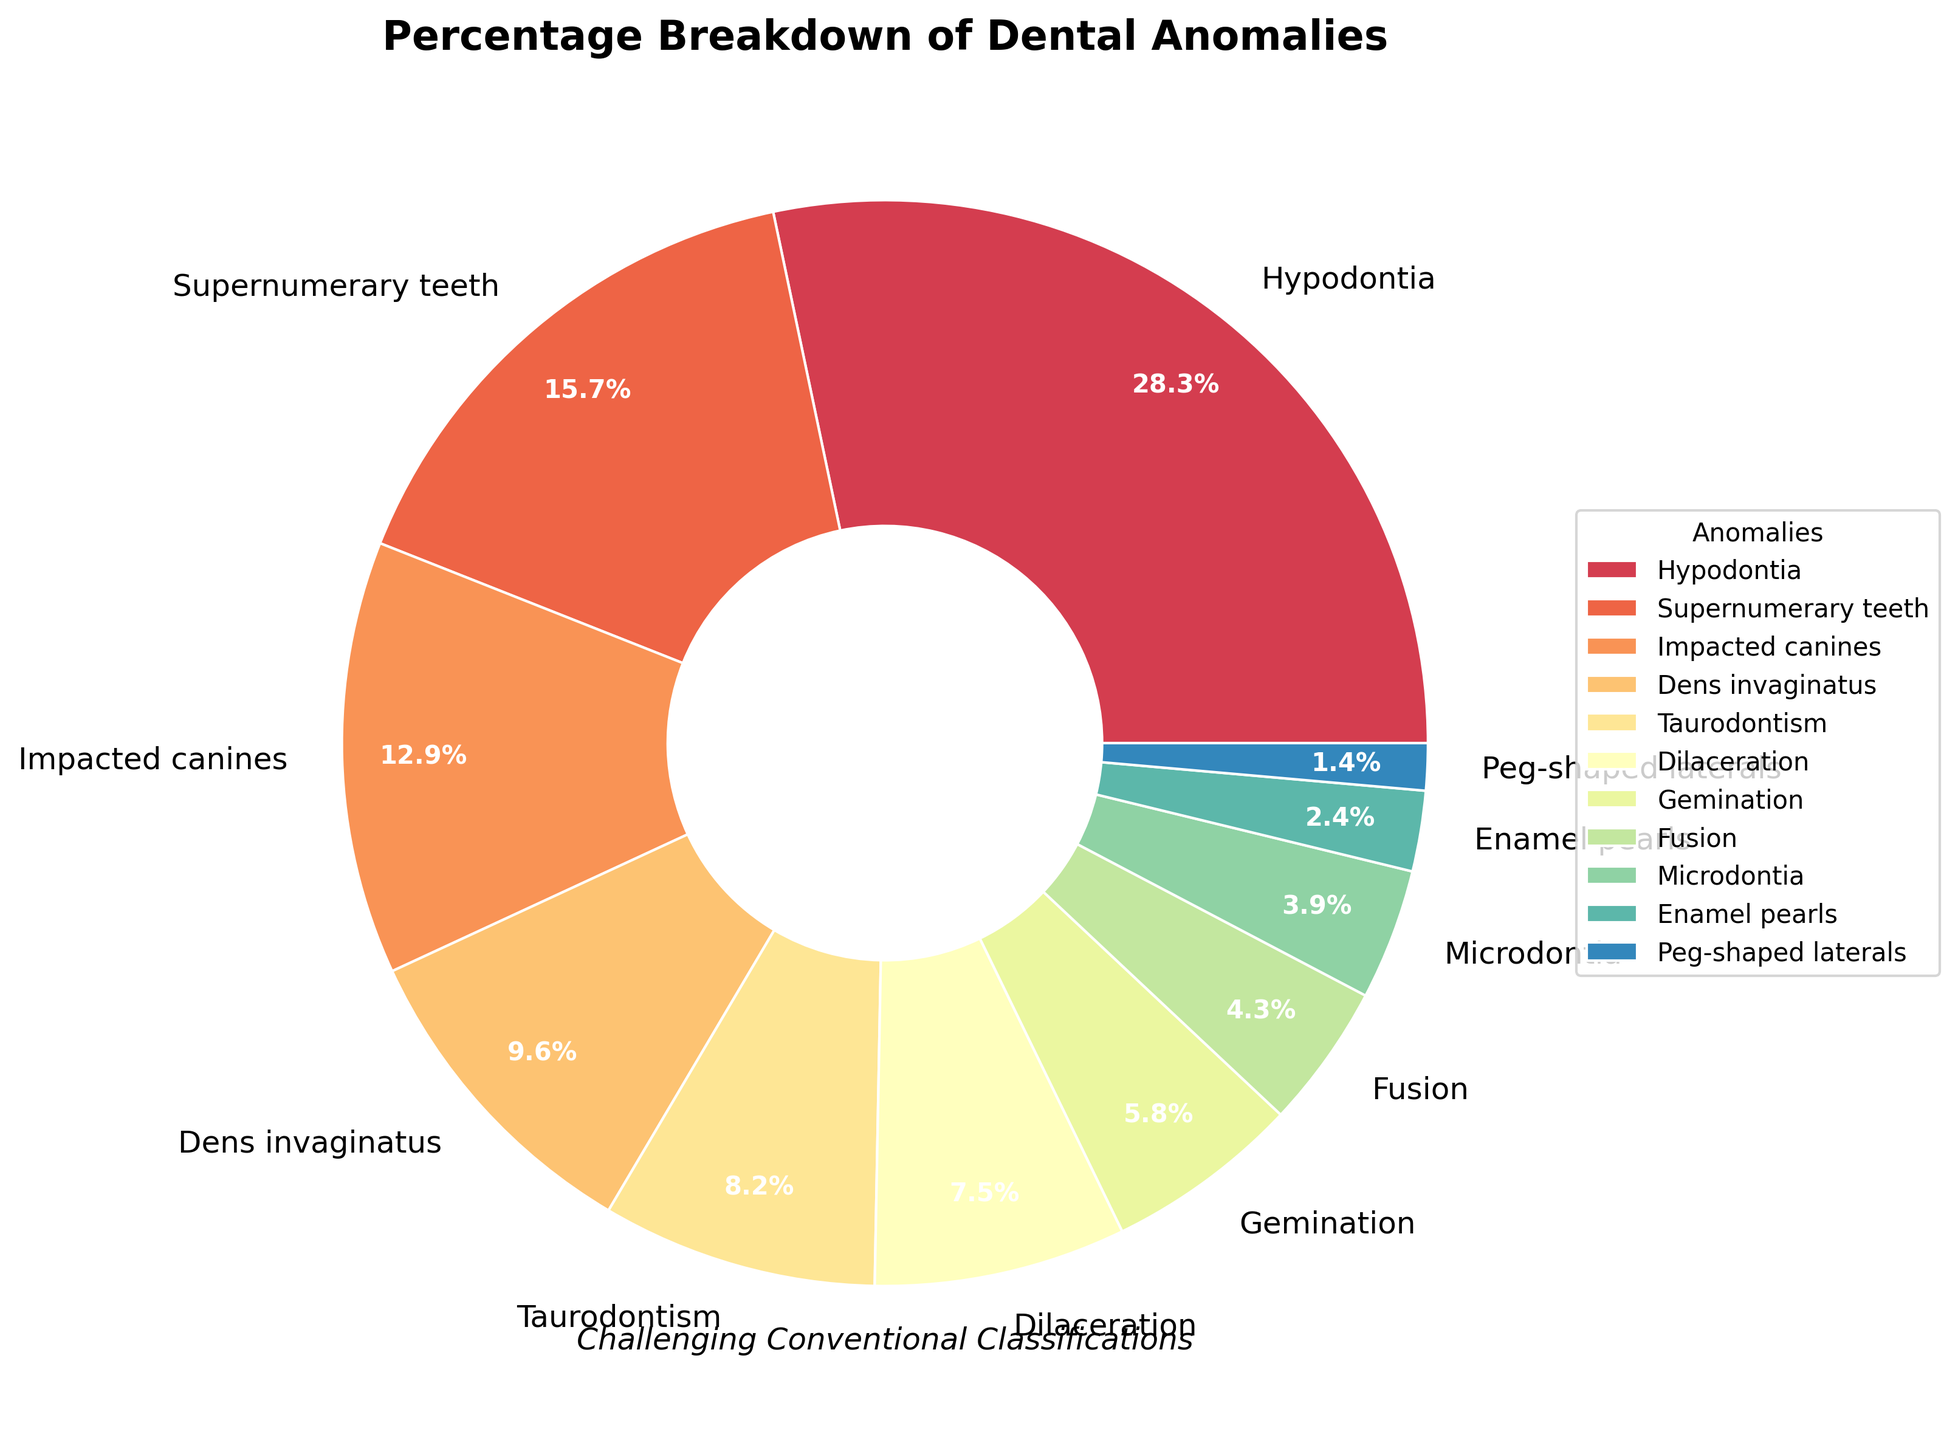Which dental anomaly has the largest percentage? The segment with the largest percentage should be identified by checking the labels and the autopct values in the pie chart. Here, "Hypodontia" takes up the largest segment.
Answer: Hypodontia How much larger is the percentage of Hypodontia compared to Supernumerary teeth? Subtract the percentage value of Supernumerary teeth from that of Hypodontia: 28.3% - 15.7% = 12.6%.
Answer: 12.6% What is the sum of the percentages for the least common five dental anomalies? Add the percentages of the least common five anomalies: Peg-shaped laterals (1.4%) + Enamel pearls (2.4%) + Microdontia (3.9%) + Fusion (4.3%) + Gemination (5.8%) = 17.8%.
Answer: 17.8% Which anomaly has a smaller percentage, Taurodontism or Dilaceration? Compare the percentage values of Taurodontism (8.2%) and Dilaceration (7.5%). Taurodontism is larger, so Dilaceration is smaller.
Answer: Dilaceration What percentage of the total does the top three anomalies account for? Add the percentages of the top three anomalies (Hypodontia, Supernumerary teeth, and Impacted canines): 28.3% + 15.7% + 12.9% = 56.9%.
Answer: 56.9% What is the difference in percentage between Dens invaginatus and Taurodontism? Subtract the percentage of Taurodontism from that of Dens invaginatus: 9.6% - 8.2% = 1.4%.
Answer: 1.4% What visual cues help you identify 'Impacted canines' quickly on the pie chart? Look for the segment labelled 'Impacted canines' and note the color used in the pie chart. The label and distinct segment visually help in identification.
Answer: Label and color How do the cumulative percentages of Hypodontia and Supernumerary teeth compare to the entire pie chart? Sum the percentages of Hypodontia (28.3%) and Supernumerary teeth (15.7%) to get their total: 28.3% + 15.7% = 44%. This represents 44% of the entire pie chart which totals 100%.
Answer: 44% Which dental anomaly has a percentage between 5% and 6%? Check the percentage values of all anomalies and identify which one fits in that range: Gemination has 5.8%.
Answer: Gemination 